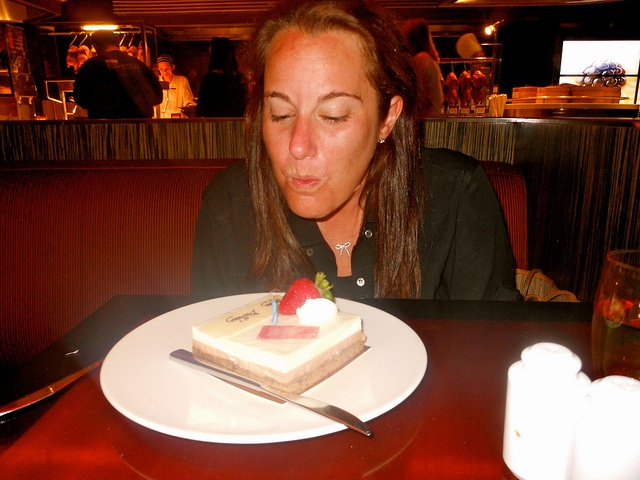Describe the objects in this image and their specific colors. I can see people in brown, black, maroon, and salmon tones, cake in brown, ivory, tan, and salmon tones, people in brown, black, maroon, and red tones, cup in brown, maroon, and black tones, and people in black, maroon, and brown tones in this image. 